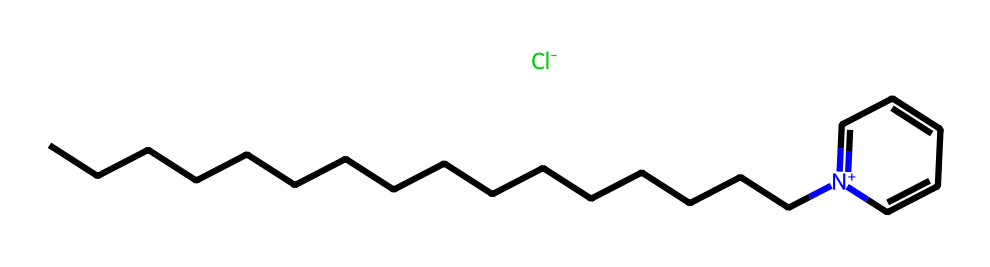What is the main functional group present in cetylpyridinium chloride? The chemical structure shows a nitrogen atom with a positive charge ([N+]), indicating that it is a quaternary ammonium compound, which is a type of functional group found in surfactants.
Answer: quaternary ammonium How many carbon atoms are in cetylpyridinium chloride? By examining the carbon chain (CCCCCCCCCCCCCCCC), there are 16 carbon atoms in total, including those in the pyridine ring.
Answer: 16 What is the presence of chlorine atom indicative of in cetylpyridinium chloride? The chlorine atom ([Cl-]) suggests that this compound is a salt. In the context of surfactants, it indicates that cetylpyridinium chloride is used as a cationic surfactant, which can impart antimicrobial properties.
Answer: salt What role does the long carbon chain play in cetylpyridinium chloride? The long carbon chain (CCCCCCCCCCCCCCCC) contributes to the hydrophobic characteristic of the molecule, which is essential for the surfactant's ability to interact with oils and organic materials.
Answer: hydrophobic interaction How many double bonds are in the ring structure of cetylpyridinium chloride? The structure of the pyridine ring is shown as containing three double bonds (as indicated by alternating single and double bonds). This is typical for aromatic ring structures.
Answer: 3 Why is cetylpyridinium chloride effective as a cationic surfactant? The presence of both a long hydrophobic carbon chain and a positively charged nitrogen atom makes cetylpyridinium chloride effective at reducing surface tension and allowing for interaction with negatively charged surfaces, like bacteria.
Answer: reduces surface tension 